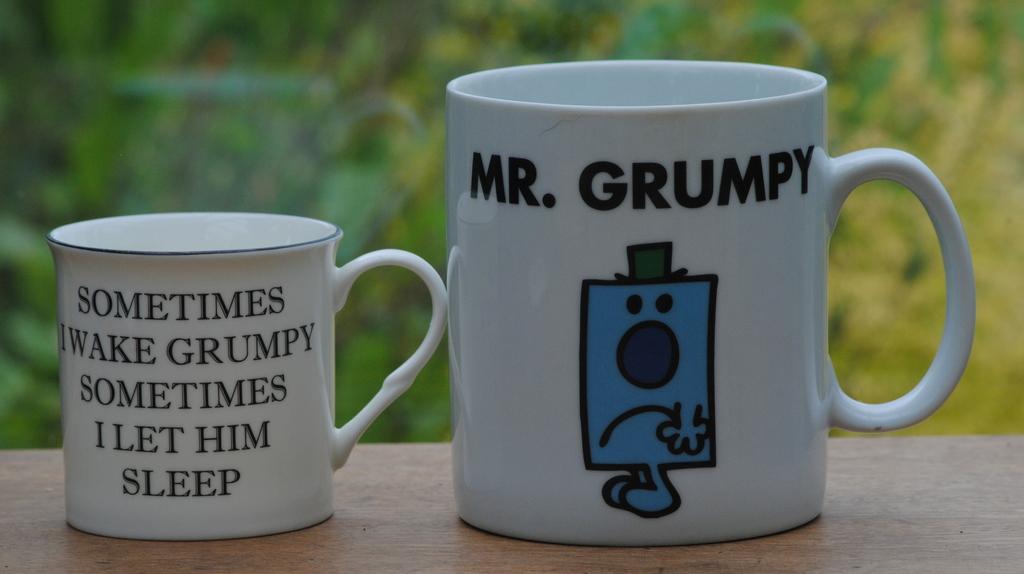What does it say above the blue cartoon?
Offer a terse response. Mr. grumpy. What does  the face of the character  signify?
Make the answer very short. Grumpy. 